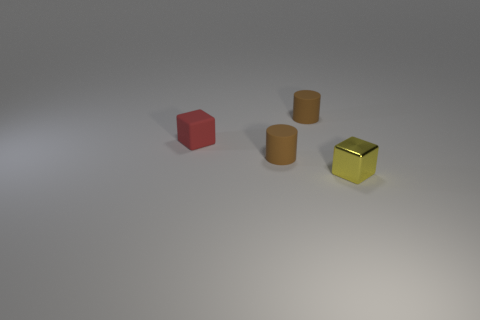Add 3 tiny red objects. How many objects exist? 7 Subtract 0 cyan balls. How many objects are left? 4 Subtract all small blocks. Subtract all tiny blue shiny blocks. How many objects are left? 2 Add 4 cylinders. How many cylinders are left? 6 Add 2 small cyan objects. How many small cyan objects exist? 2 